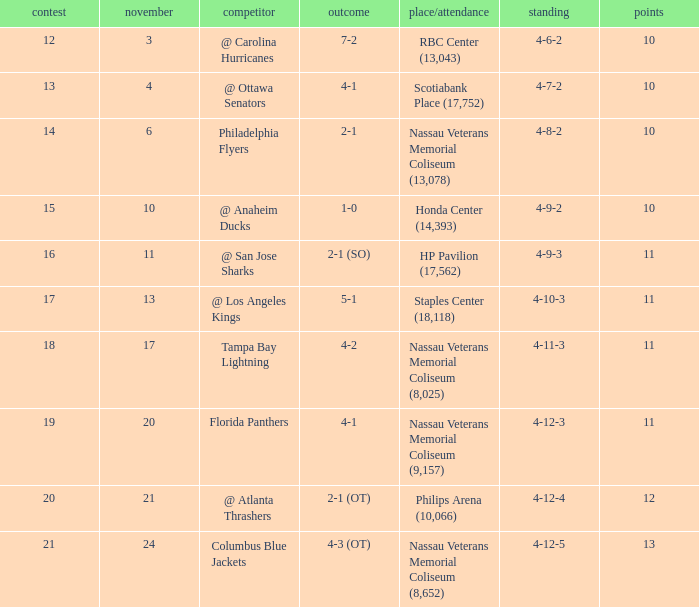What is each record for game 13? 4-7-2. 